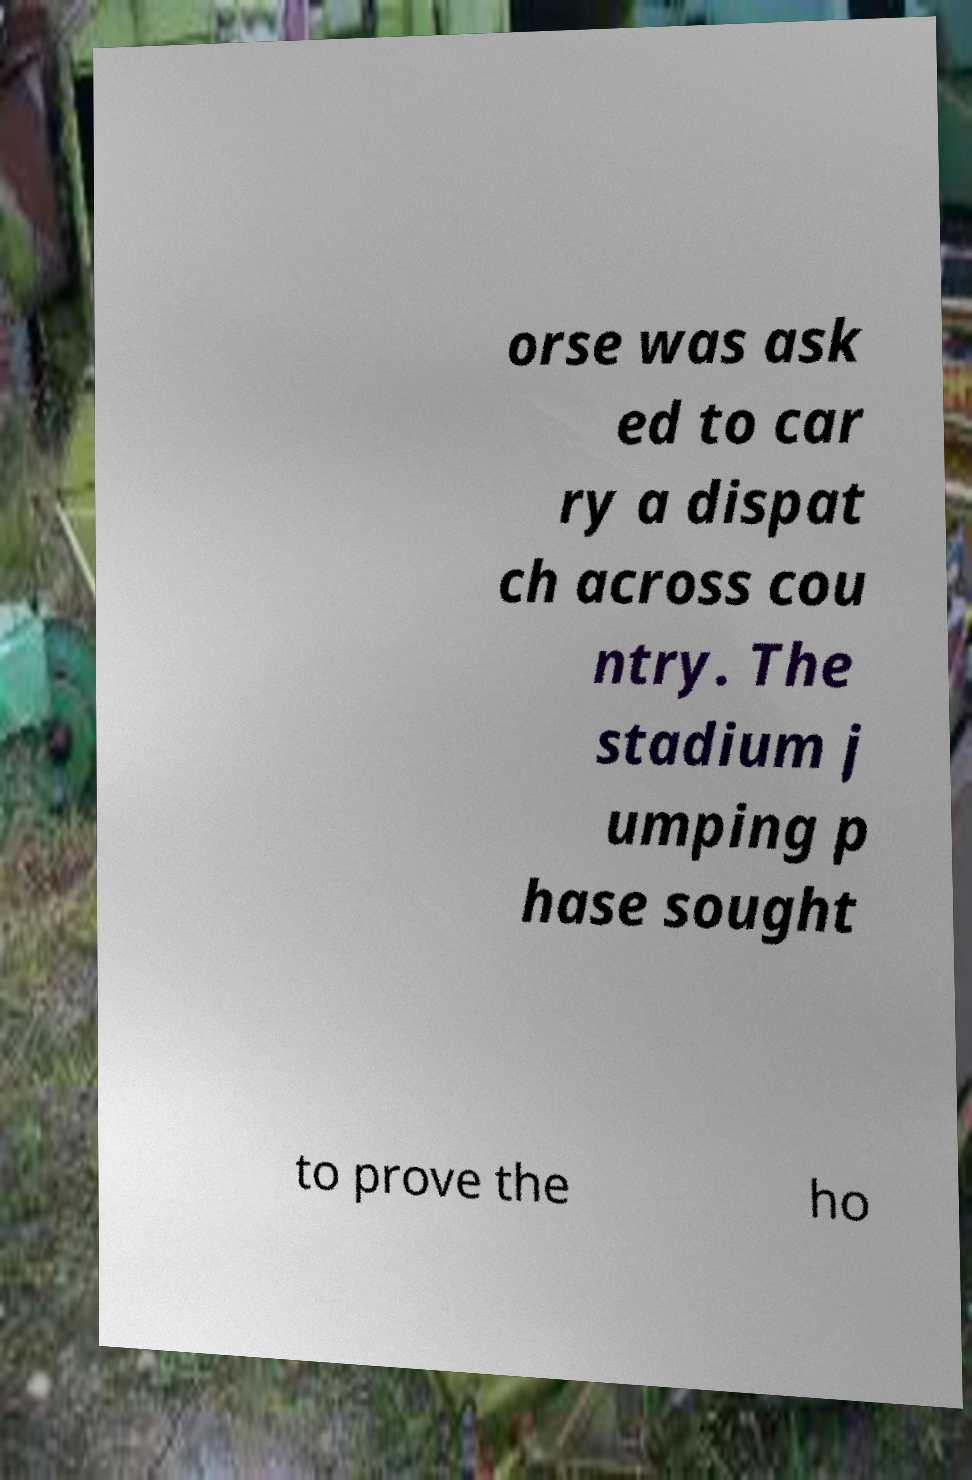Could you assist in decoding the text presented in this image and type it out clearly? orse was ask ed to car ry a dispat ch across cou ntry. The stadium j umping p hase sought to prove the ho 